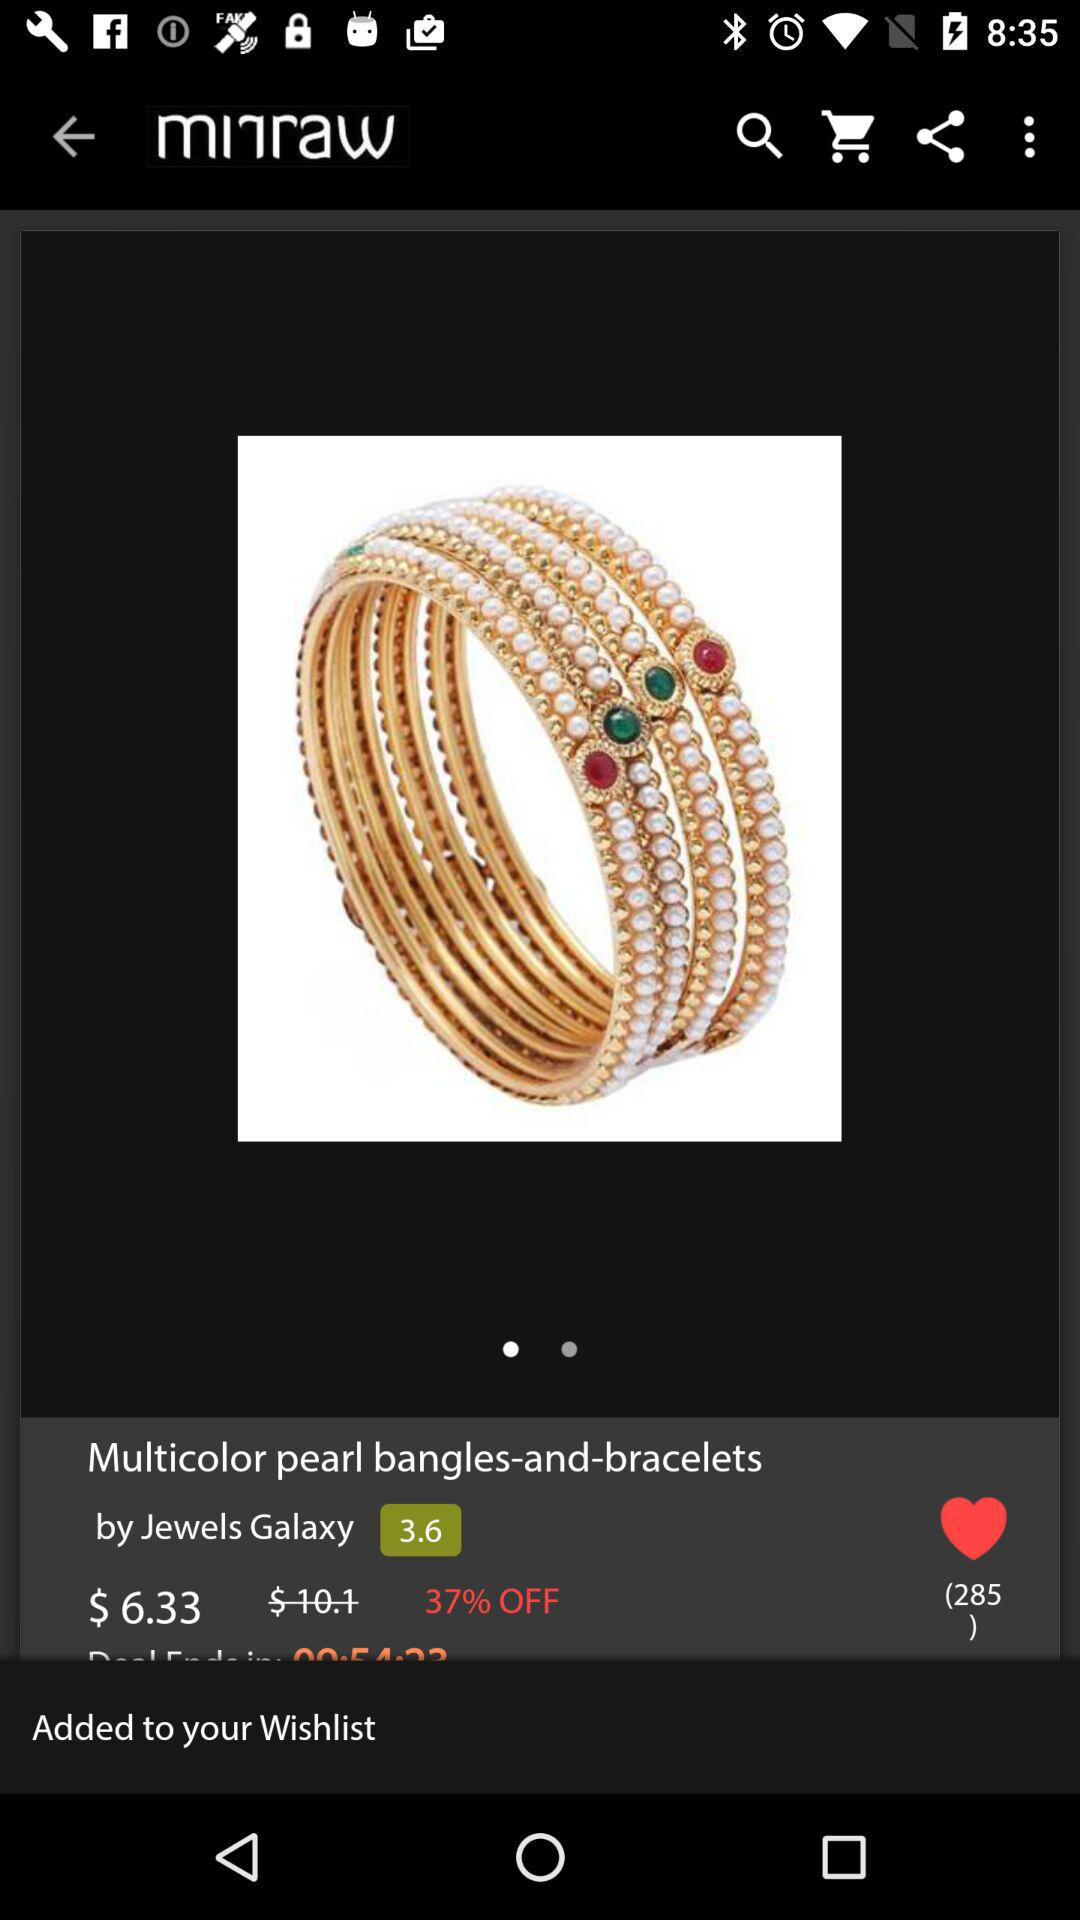What is the price of the product?
Answer the question using a single word or phrase. $6.33 